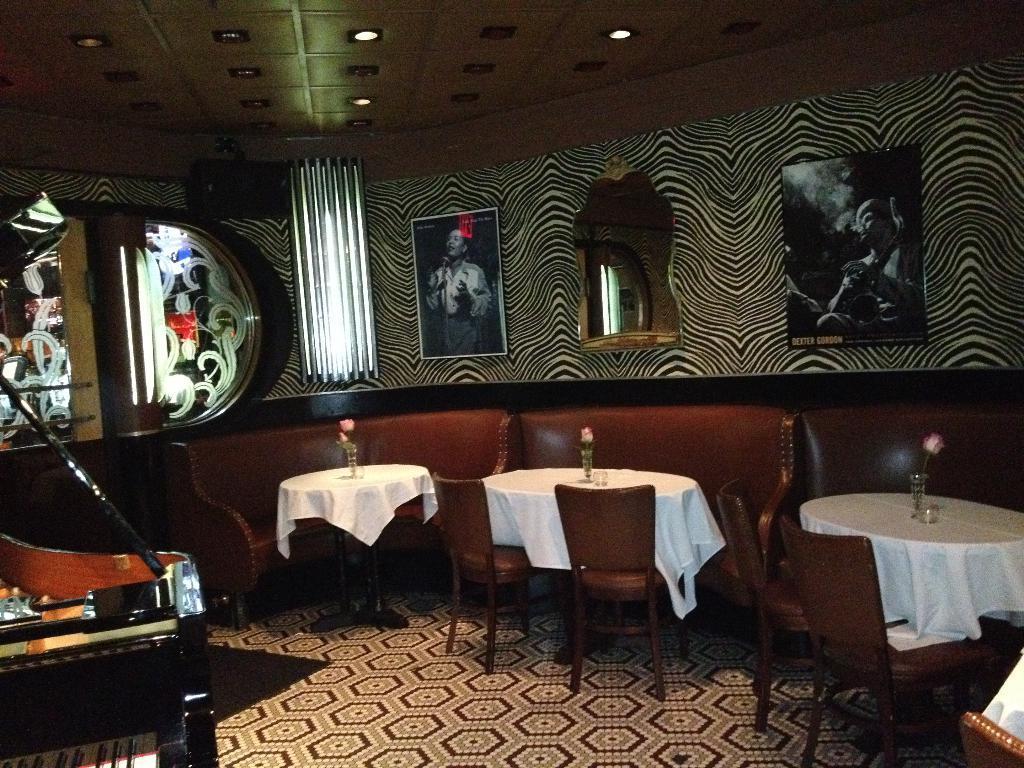Please provide a concise description of this image. In this image, we can see a room where there are some photos which are place on the wall and the wall is of black stripes. There is also a light over here and there are some chairs and tables with a flower on each table and there is a musical instrument to the left side of the image and the floor is covered with a carpet. 